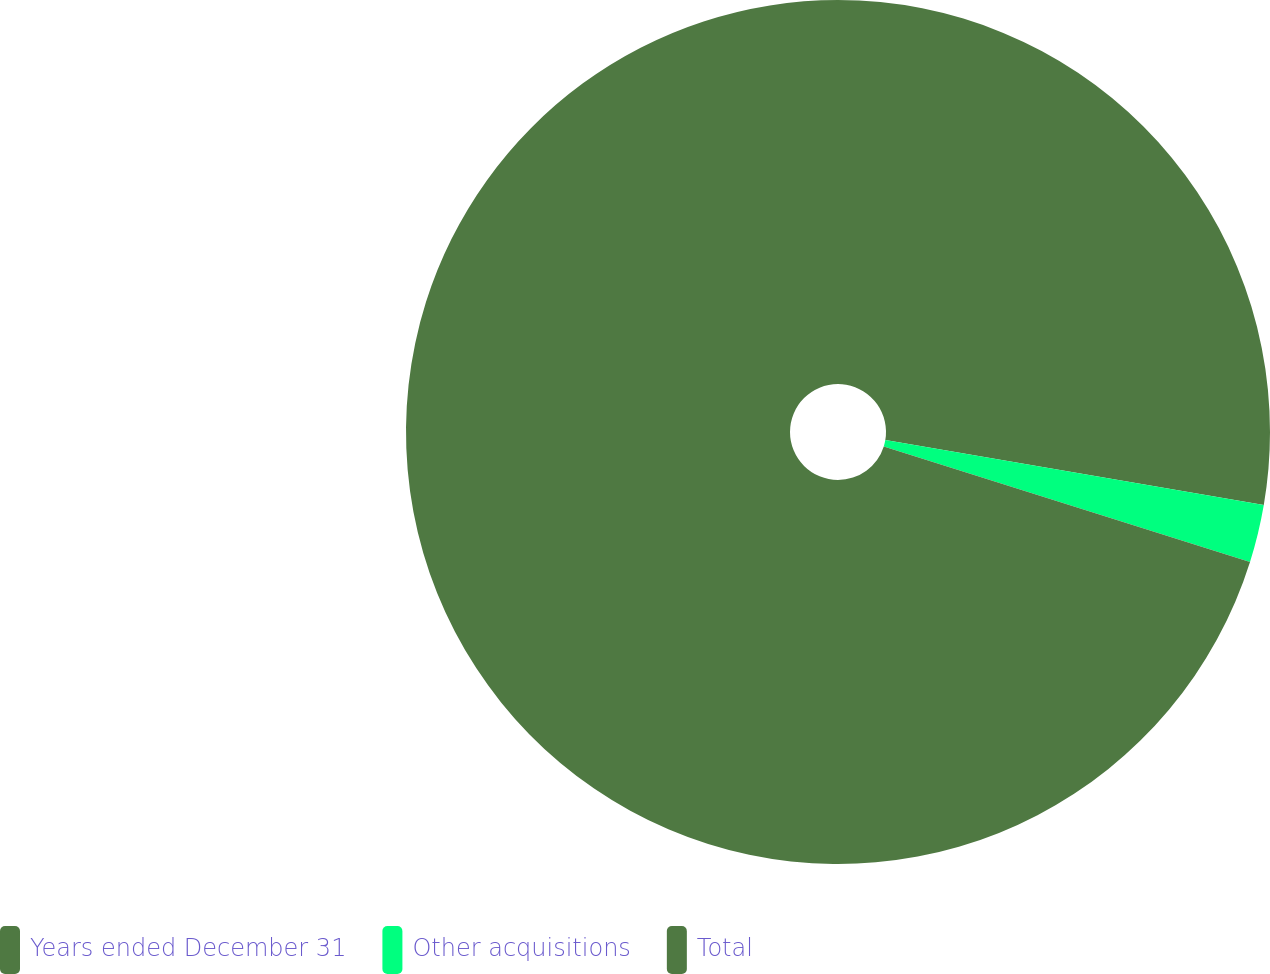Convert chart. <chart><loc_0><loc_0><loc_500><loc_500><pie_chart><fcel>Years ended December 31<fcel>Other acquisitions<fcel>Total<nl><fcel>27.7%<fcel>2.16%<fcel>70.14%<nl></chart> 